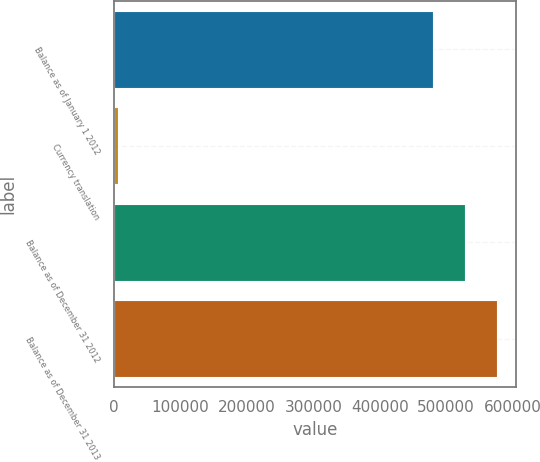Convert chart. <chart><loc_0><loc_0><loc_500><loc_500><bar_chart><fcel>Balance as of January 1 2012<fcel>Currency translation<fcel>Balance as of December 31 2012<fcel>Balance as of December 31 2013<nl><fcel>479402<fcel>5484<fcel>528106<fcel>576810<nl></chart> 